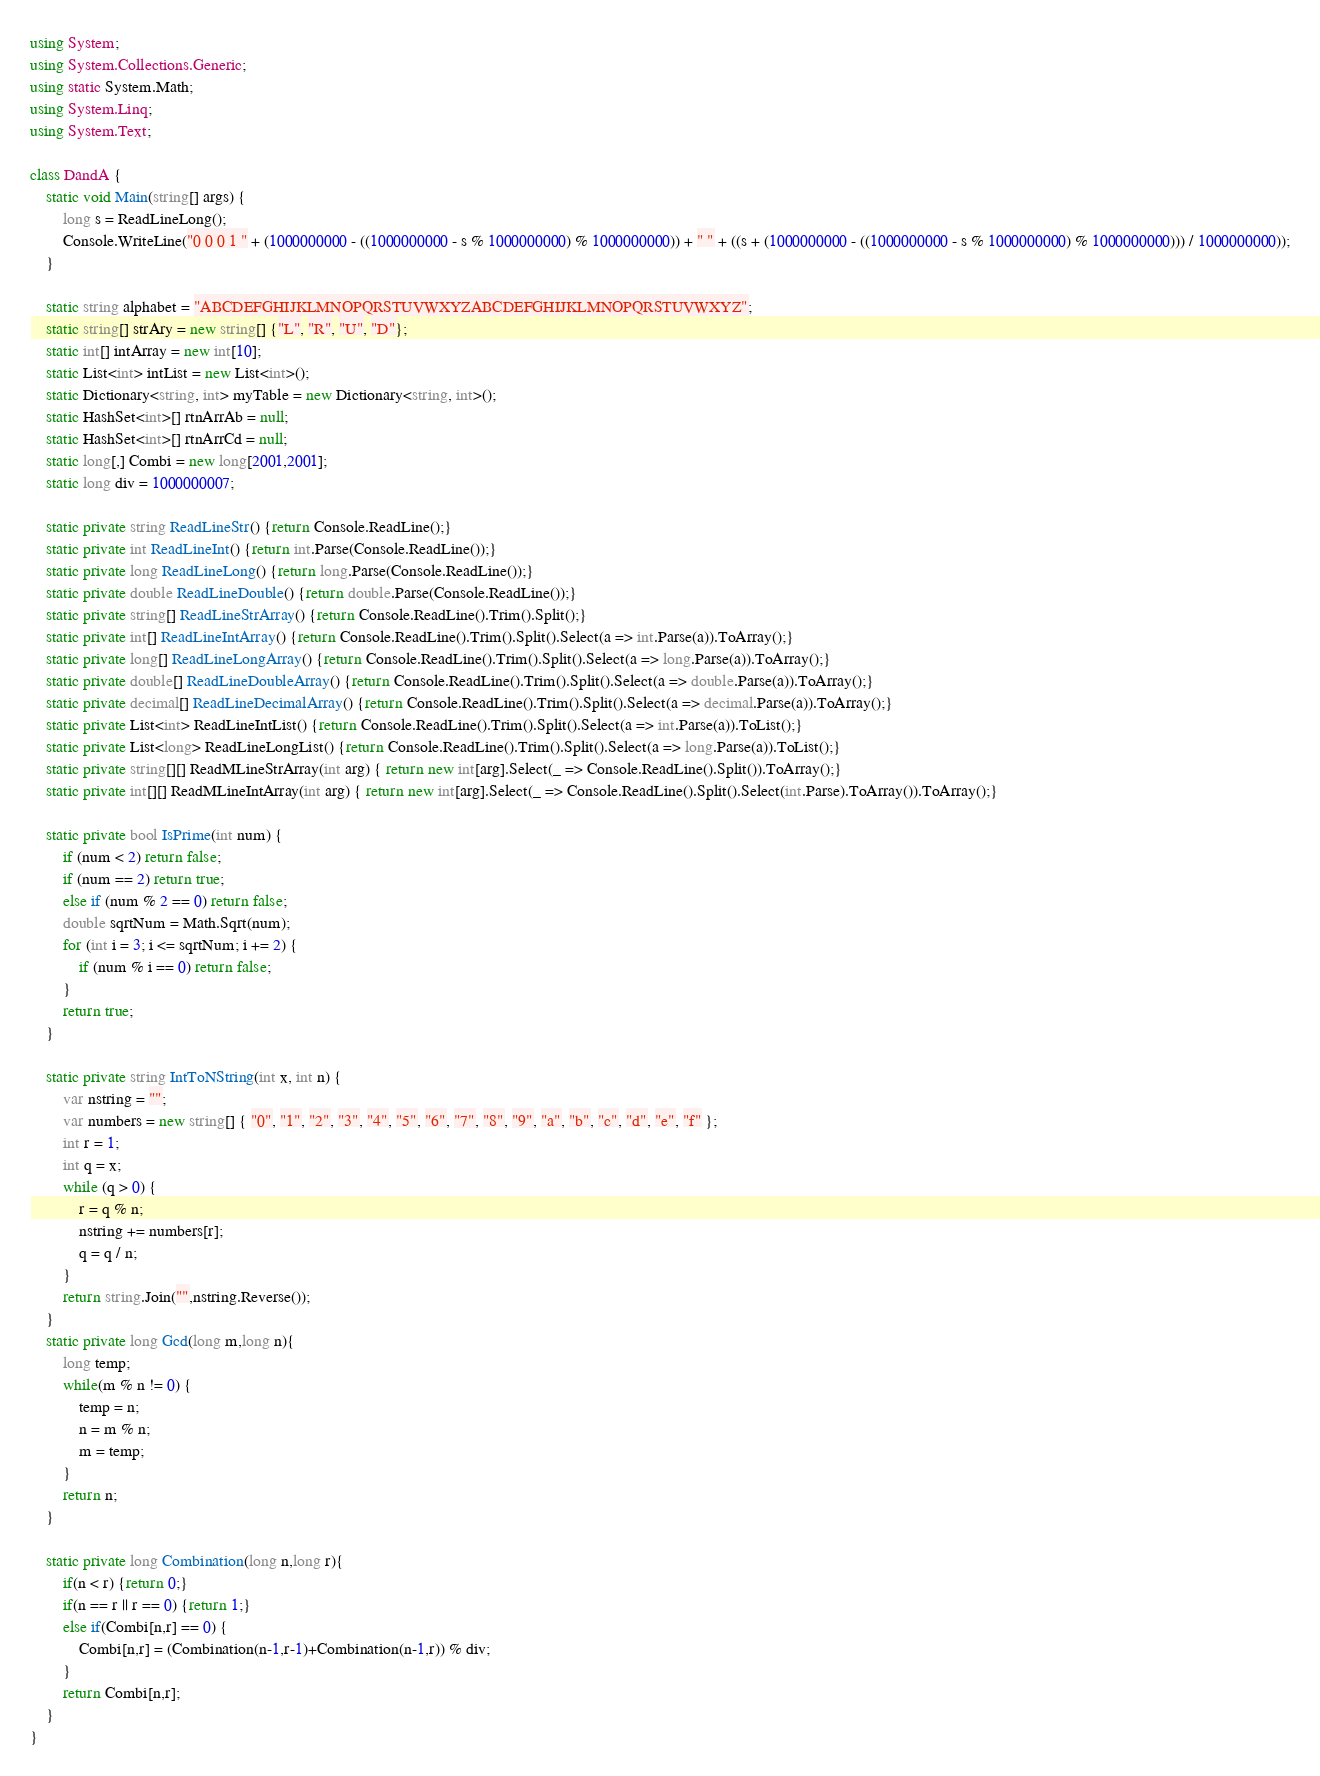Convert code to text. <code><loc_0><loc_0><loc_500><loc_500><_C#_>using System;
using System.Collections.Generic;
using static System.Math;
using System.Linq;
using System.Text;
 
class DandA {
    static void Main(string[] args) {
        long s = ReadLineLong();
        Console.WriteLine("0 0 0 1 " + (1000000000 - ((1000000000 - s % 1000000000) % 1000000000)) + " " + ((s + (1000000000 - ((1000000000 - s % 1000000000) % 1000000000))) / 1000000000));
    }
 
    static string alphabet = "ABCDEFGHIJKLMNOPQRSTUVWXYZABCDEFGHIJKLMNOPQRSTUVWXYZ";
    static string[] strAry = new string[] {"L", "R", "U", "D"};
    static int[] intArray = new int[10];
    static List<int> intList = new List<int>();
    static Dictionary<string, int> myTable = new Dictionary<string, int>();
    static HashSet<int>[] rtnArrAb = null;
    static HashSet<int>[] rtnArrCd = null;
    static long[,] Combi = new long[2001,2001];
    static long div = 1000000007;
  
    static private string ReadLineStr() {return Console.ReadLine();}
    static private int ReadLineInt() {return int.Parse(Console.ReadLine());}
    static private long ReadLineLong() {return long.Parse(Console.ReadLine());}
    static private double ReadLineDouble() {return double.Parse(Console.ReadLine());}
    static private string[] ReadLineStrArray() {return Console.ReadLine().Trim().Split();}
    static private int[] ReadLineIntArray() {return Console.ReadLine().Trim().Split().Select(a => int.Parse(a)).ToArray();}
    static private long[] ReadLineLongArray() {return Console.ReadLine().Trim().Split().Select(a => long.Parse(a)).ToArray();}
    static private double[] ReadLineDoubleArray() {return Console.ReadLine().Trim().Split().Select(a => double.Parse(a)).ToArray();}
    static private decimal[] ReadLineDecimalArray() {return Console.ReadLine().Trim().Split().Select(a => decimal.Parse(a)).ToArray();}
    static private List<int> ReadLineIntList() {return Console.ReadLine().Trim().Split().Select(a => int.Parse(a)).ToList();}
    static private List<long> ReadLineLongList() {return Console.ReadLine().Trim().Split().Select(a => long.Parse(a)).ToList();}
    static private string[][] ReadMLineStrArray(int arg) { return new int[arg].Select(_ => Console.ReadLine().Split()).ToArray();}
    static private int[][] ReadMLineIntArray(int arg) { return new int[arg].Select(_ => Console.ReadLine().Split().Select(int.Parse).ToArray()).ToArray();}
 
    static private bool IsPrime(int num) {
        if (num < 2) return false;
        if (num == 2) return true;
        else if (num % 2 == 0) return false;
        double sqrtNum = Math.Sqrt(num);
        for (int i = 3; i <= sqrtNum; i += 2) {
            if (num % i == 0) return false;
        }
        return true;
    }
  
    static private string IntToNString(int x, int n) {
        var nstring = "";
        var numbers = new string[] { "0", "1", "2", "3", "4", "5", "6", "7", "8", "9", "a", "b", "c", "d", "e", "f" };
        int r = 1;
        int q = x;
        while (q > 0) {
            r = q % n;
            nstring += numbers[r];
            q = q / n;
        }
        return string.Join("",nstring.Reverse());
    }
    static private long Gcd(long m,long n){
        long temp;
        while(m % n != 0) {
            temp = n;
            n = m % n;
            m = temp;
        }
        return n;
    }
 
    static private long Combination(long n,long r){
        if(n < r) {return 0;}
        if(n == r || r == 0) {return 1;}
        else if(Combi[n,r] == 0) {
            Combi[n,r] = (Combination(n-1,r-1)+Combination(n-1,r)) % div;
        }
        return Combi[n,r];
    }
}</code> 